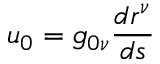Convert formula to latex. <formula><loc_0><loc_0><loc_500><loc_500>u _ { 0 } = g _ { 0 \nu } \frac { d r ^ { \nu } } { d s }</formula> 